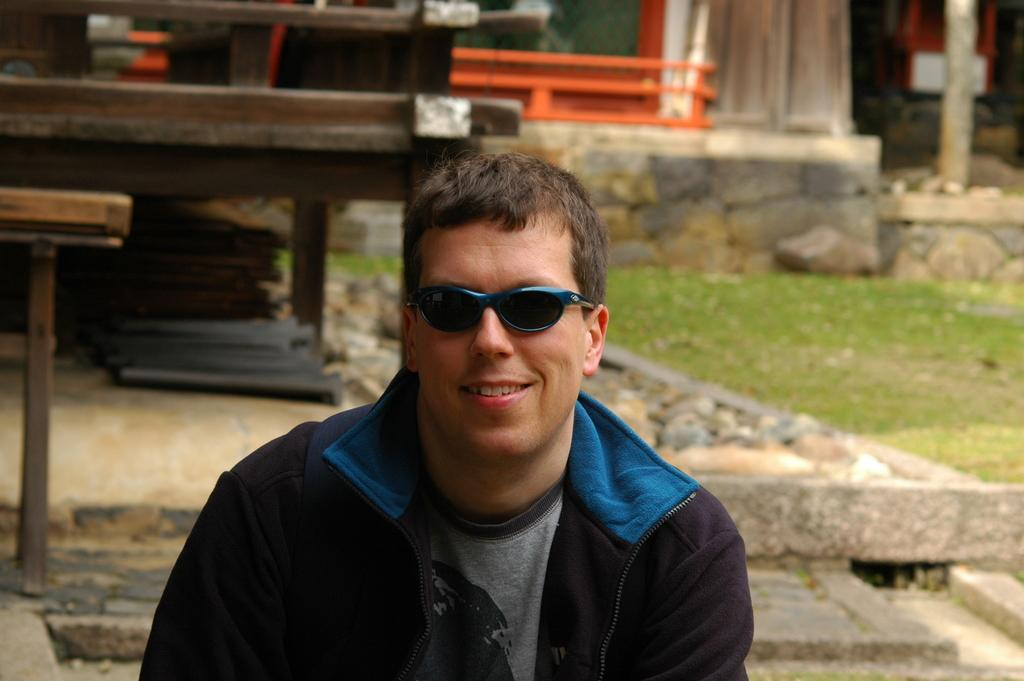What type of objects are made of wood in the image? There are wooden objects in the image. Who is present in the image? There is a person in the image. What is the person wearing? The person is wearing clothes. What accessory is the person wearing? The person is wearing sunglasses. Can you describe the background of the image? The background of the image is blurred. How many matches are visible on the tray in the image? There is no tray or matches present in the image. What type of chairs can be seen in the background of the image? There are no chairs visible in the image; the background is blurred. 